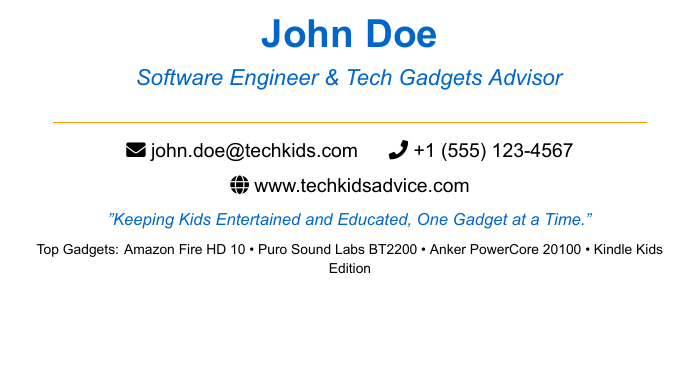what is the name on the business card? The name displayed prominently on the card is "John Doe."
Answer: John Doe what is the main title of the individual? The main title listed under the name is "Software Engineer & Tech Gadgets Advisor."
Answer: Software Engineer & Tech Gadgets Advisor what is the email address provided? The email address shown on the card is john.doe@techkids.com.
Answer: john.doe@techkids.com what are the top gadgets listed? The card lists four top gadgets: Amazon Fire HD 10, Puro Sound Labs BT2200, Anker PowerCore 20100, and Kindle Kids Edition.
Answer: Amazon Fire HD 10 • Puro Sound Labs BT2200 • Anker PowerCore 20100 • Kindle Kids Edition what is the quote on the card? The card features the quote "Keeping Kids Entertained and Educated, One Gadget at a Time."
Answer: Keeping Kids Entertained and Educated, One Gadget at a Time how can you contact John Doe by phone? The phone number provided on the card is +1 (555) 123-4567.
Answer: +1 (555) 123-4567 what is the website listed on the business card? The website displayed on the card is www.techkidsadvice.com.
Answer: www.techkidsadvice.com where is the QR code pointing to? The QR code directs users to the website mentioned on the card, which is www.techkidsadvice.com.
Answer: www.techkidsadvice.com what color is used for the primary text on the card? The primary color used for the text is blue, specifically RGB(0,102,204).
Answer: blue 